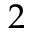<formula> <loc_0><loc_0><loc_500><loc_500>2</formula> 